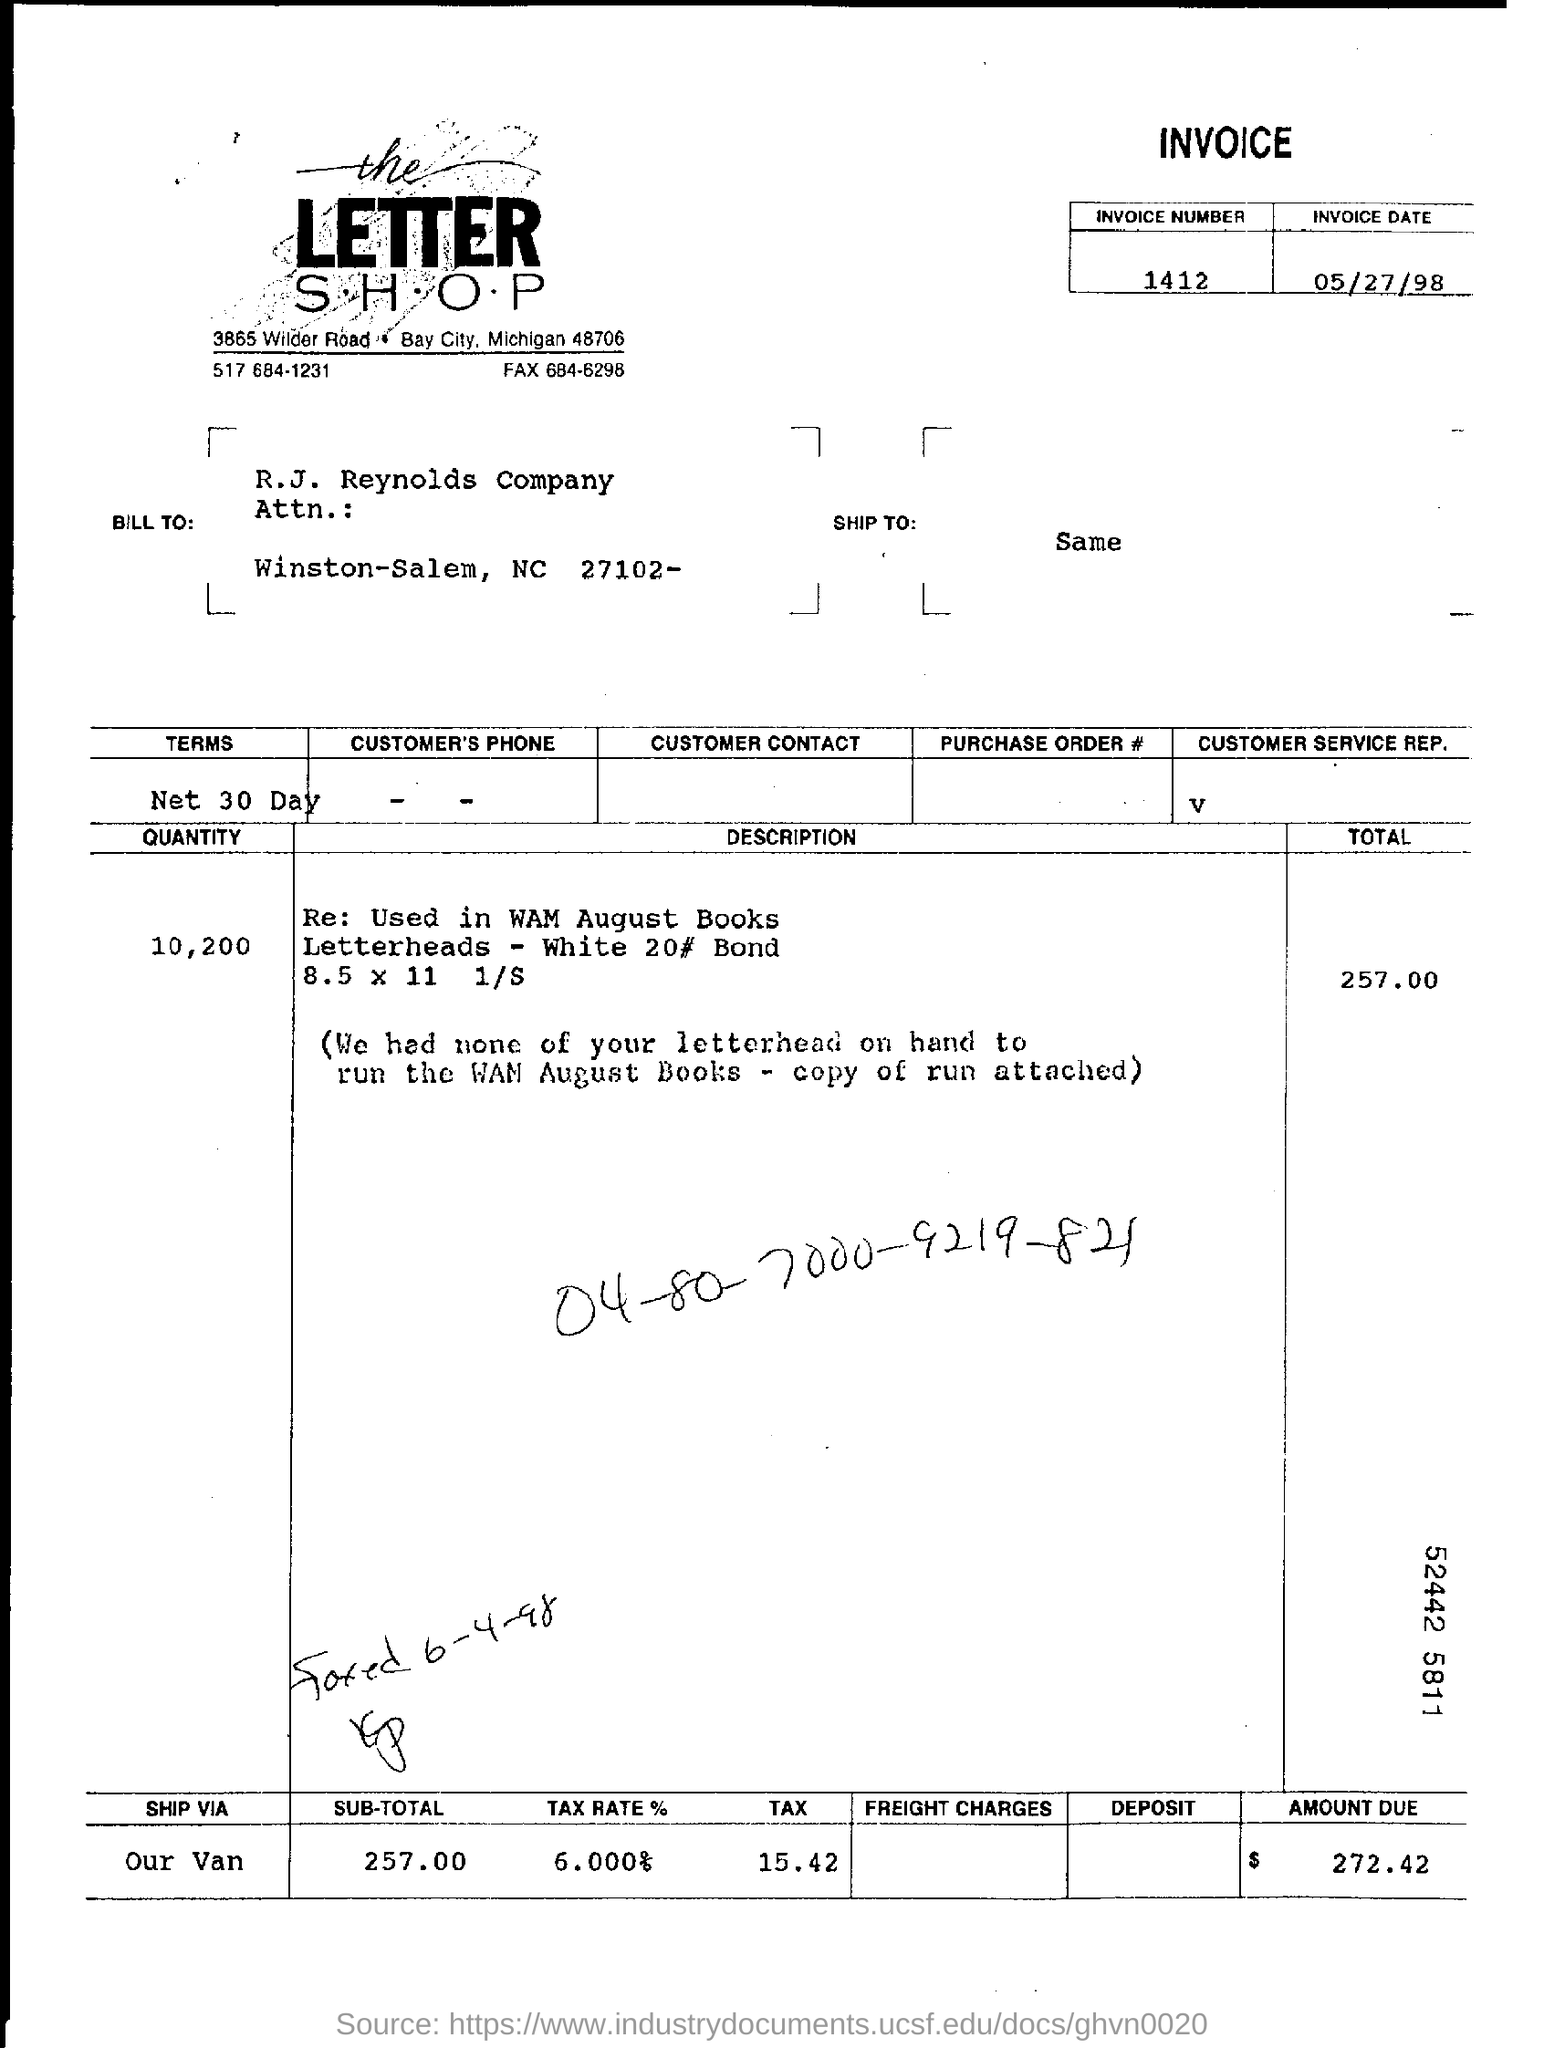Draw attention to some important aspects in this diagram. The amount due is $272.42. The invoice date is May 27, 1998. The invoice number is 1412. The tax rate is 6.000%. 